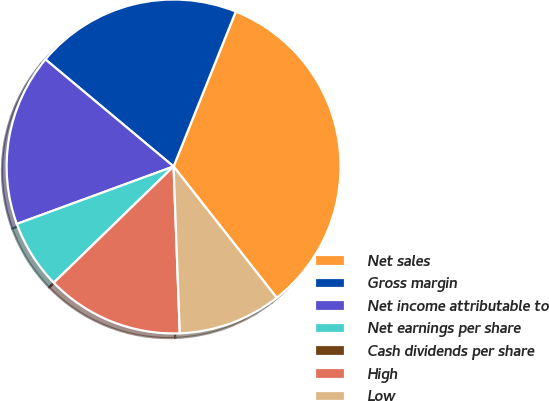Convert chart to OTSL. <chart><loc_0><loc_0><loc_500><loc_500><pie_chart><fcel>Net sales<fcel>Gross margin<fcel>Net income attributable to<fcel>Net earnings per share<fcel>Cash dividends per share<fcel>High<fcel>Low<nl><fcel>33.33%<fcel>20.0%<fcel>16.67%<fcel>6.67%<fcel>0.0%<fcel>13.33%<fcel>10.0%<nl></chart> 